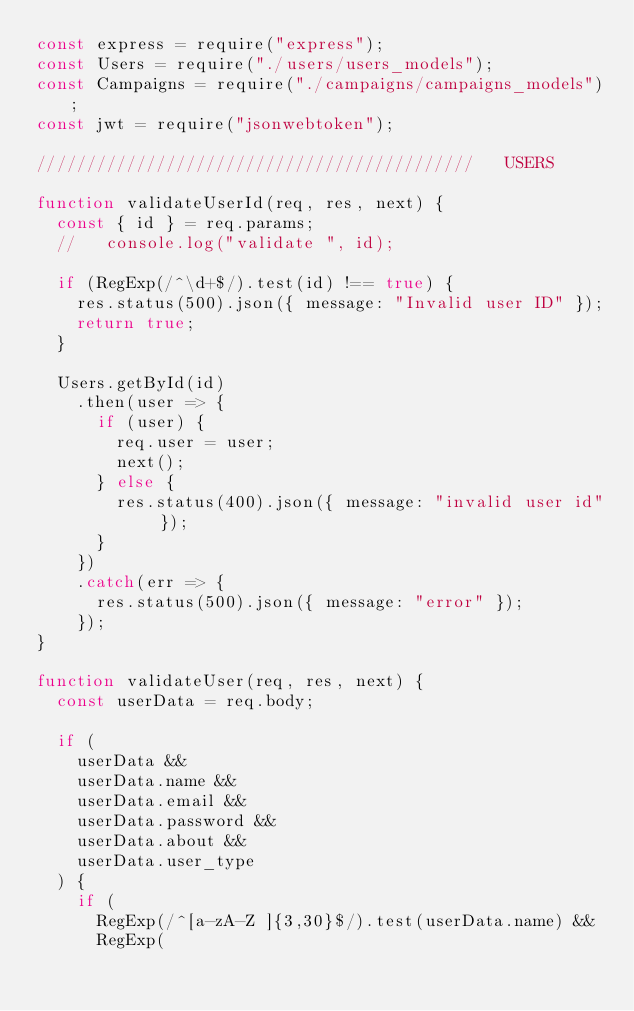Convert code to text. <code><loc_0><loc_0><loc_500><loc_500><_JavaScript_>const express = require("express");
const Users = require("./users/users_models");
const Campaigns = require("./campaigns/campaigns_models");
const jwt = require("jsonwebtoken");

////////////////////////////////////////////   USERS

function validateUserId(req, res, next) {
  const { id } = req.params;
  //   console.log("validate ", id);

  if (RegExp(/^\d+$/).test(id) !== true) {
    res.status(500).json({ message: "Invalid user ID" });
    return true;
  }

  Users.getById(id)
    .then(user => {
      if (user) {
        req.user = user;
        next();
      } else {
        res.status(400).json({ message: "invalid user id" });
      }
    })
    .catch(err => {
      res.status(500).json({ message: "error" });
    });
}

function validateUser(req, res, next) {
  const userData = req.body;

  if (
    userData &&
    userData.name &&
    userData.email &&
    userData.password &&
    userData.about &&
    userData.user_type
  ) {
    if (
      RegExp(/^[a-zA-Z ]{3,30}$/).test(userData.name) &&
      RegExp(</code> 